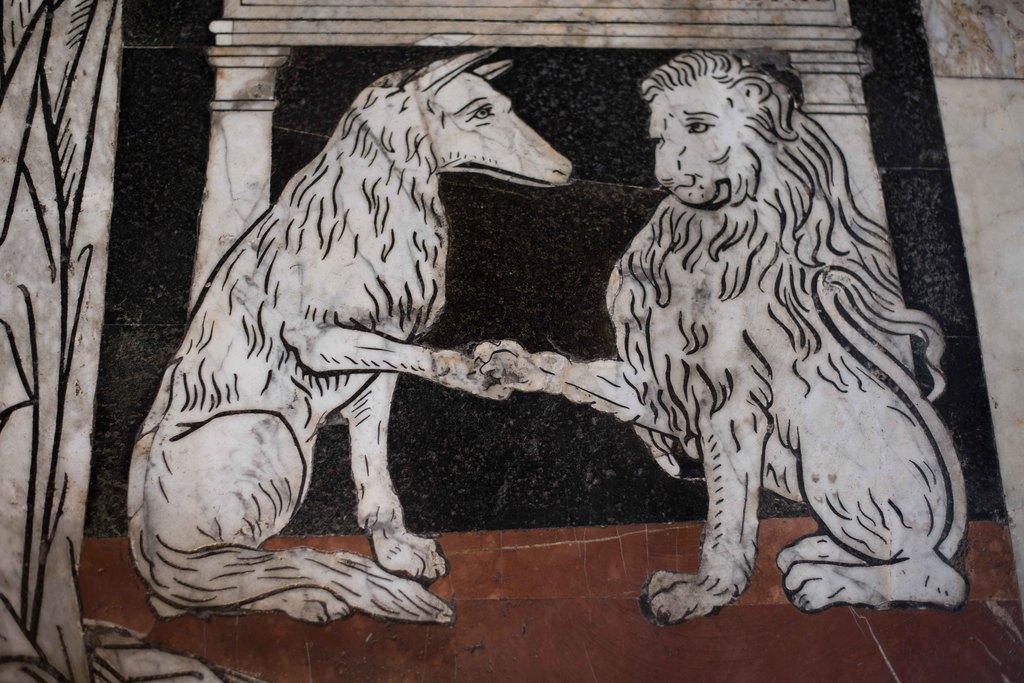Can you describe this image briefly? In this picture, we see the sketch of the lion and an animal which looks like a dog. In the background, it is in white, black and brown color. It might be a wall. 